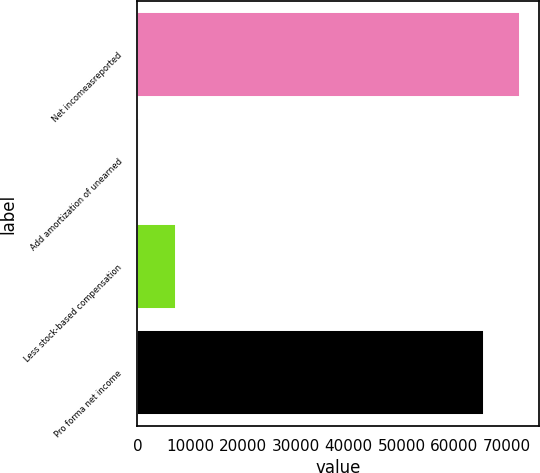Convert chart. <chart><loc_0><loc_0><loc_500><loc_500><bar_chart><fcel>Net incomeasreported<fcel>Add amortization of unearned<fcel>Less stock-based compensation<fcel>Pro forma net income<nl><fcel>72390.7<fcel>403<fcel>7235.7<fcel>65558<nl></chart> 